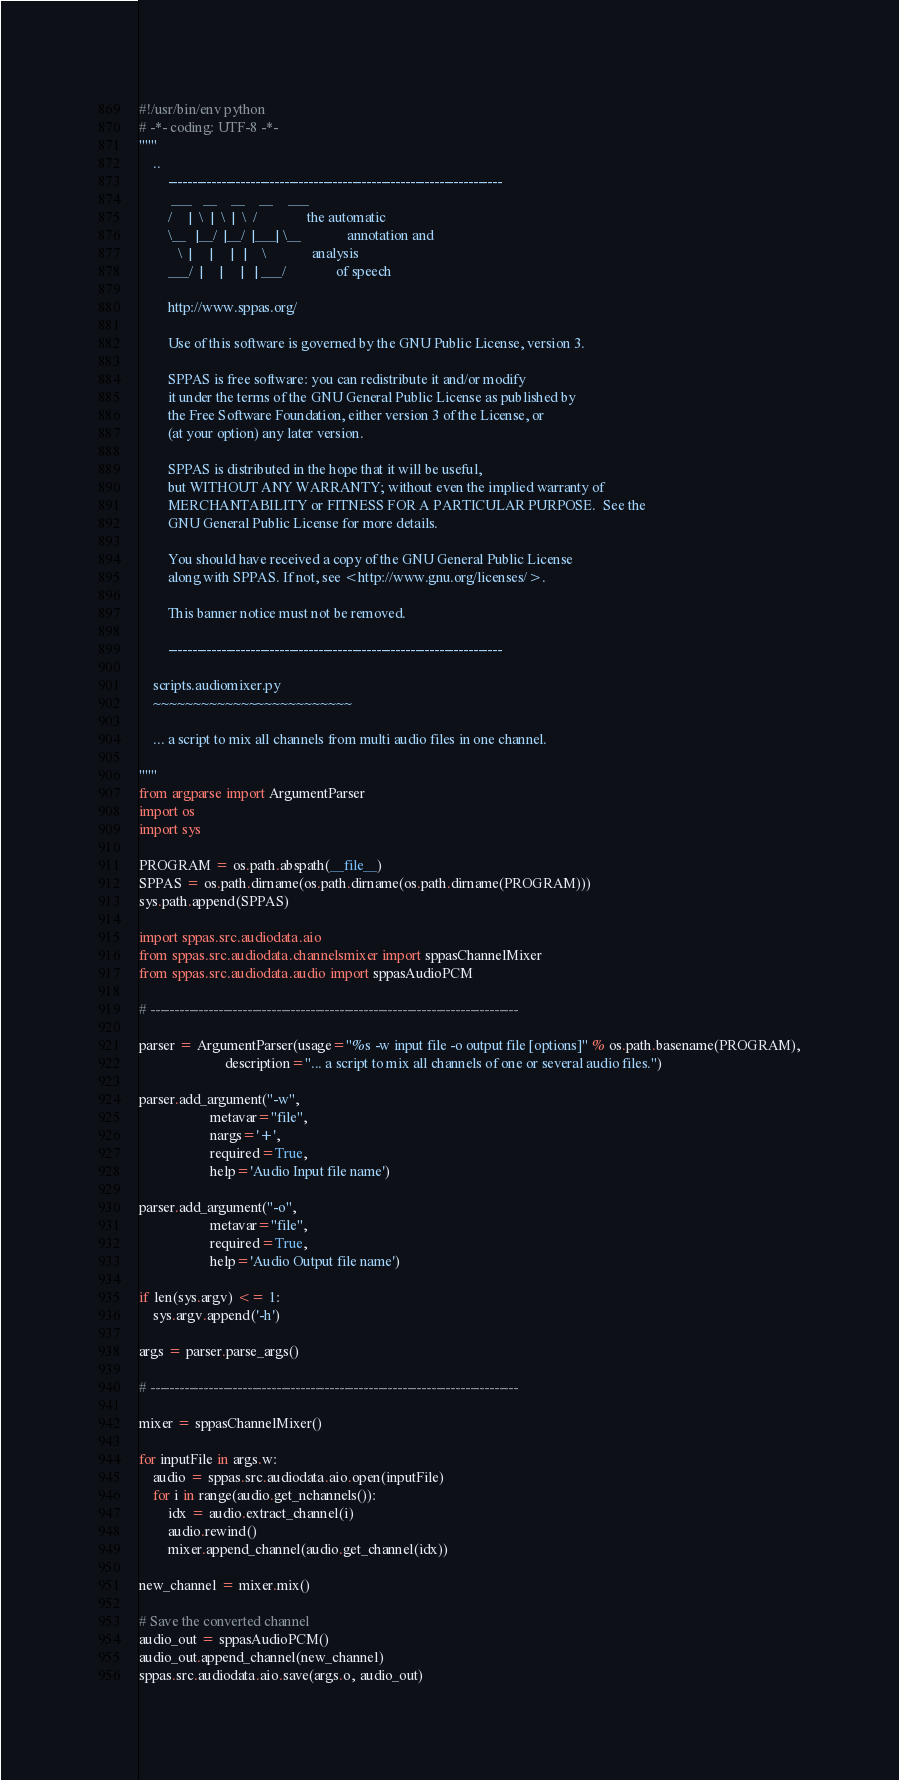<code> <loc_0><loc_0><loc_500><loc_500><_Python_>#!/usr/bin/env python
# -*- coding: UTF-8 -*-
"""
    ..
        ---------------------------------------------------------------------
         ___   __    __    __    ___
        /     |  \  |  \  |  \  /              the automatic
        \__   |__/  |__/  |___| \__             annotation and
           \  |     |     |   |    \             analysis
        ___/  |     |     |   | ___/              of speech

        http://www.sppas.org/

        Use of this software is governed by the GNU Public License, version 3.

        SPPAS is free software: you can redistribute it and/or modify
        it under the terms of the GNU General Public License as published by
        the Free Software Foundation, either version 3 of the License, or
        (at your option) any later version.

        SPPAS is distributed in the hope that it will be useful,
        but WITHOUT ANY WARRANTY; without even the implied warranty of
        MERCHANTABILITY or FITNESS FOR A PARTICULAR PURPOSE.  See the
        GNU General Public License for more details.

        You should have received a copy of the GNU General Public License
        along with SPPAS. If not, see <http://www.gnu.org/licenses/>.

        This banner notice must not be removed.

        ---------------------------------------------------------------------

    scripts.audiomixer.py
    ~~~~~~~~~~~~~~~~~~~~~~~~~

    ... a script to mix all channels from multi audio files in one channel.

"""
from argparse import ArgumentParser
import os
import sys

PROGRAM = os.path.abspath(__file__)
SPPAS = os.path.dirname(os.path.dirname(os.path.dirname(PROGRAM)))
sys.path.append(SPPAS)

import sppas.src.audiodata.aio
from sppas.src.audiodata.channelsmixer import sppasChannelMixer
from sppas.src.audiodata.audio import sppasAudioPCM

# ----------------------------------------------------------------------------

parser = ArgumentParser(usage="%s -w input file -o output file [options]" % os.path.basename(PROGRAM),
                        description="... a script to mix all channels of one or several audio files.")

parser.add_argument("-w",
                    metavar="file",
                    nargs='+',
                    required=True,
                    help='Audio Input file name')

parser.add_argument("-o",
                    metavar="file",
                    required=True,
                    help='Audio Output file name')

if len(sys.argv) <= 1:
    sys.argv.append('-h')

args = parser.parse_args()

# ----------------------------------------------------------------------------

mixer = sppasChannelMixer()

for inputFile in args.w:
    audio = sppas.src.audiodata.aio.open(inputFile)
    for i in range(audio.get_nchannels()):
        idx = audio.extract_channel(i)
        audio.rewind()
        mixer.append_channel(audio.get_channel(idx))

new_channel = mixer.mix()

# Save the converted channel
audio_out = sppasAudioPCM()
audio_out.append_channel(new_channel)
sppas.src.audiodata.aio.save(args.o, audio_out)
</code> 